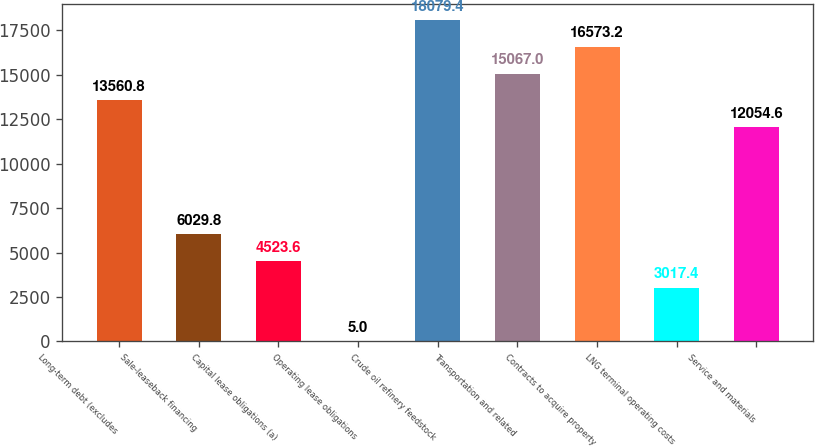<chart> <loc_0><loc_0><loc_500><loc_500><bar_chart><fcel>Long-term debt (excludes<fcel>Sale-leaseback financing<fcel>Capital lease obligations (a)<fcel>Operating lease obligations<fcel>Crude oil refinery feedstock<fcel>Transportation and related<fcel>Contracts to acquire property<fcel>LNG terminal operating costs<fcel>Service and materials<nl><fcel>13560.8<fcel>6029.8<fcel>4523.6<fcel>5<fcel>18079.4<fcel>15067<fcel>16573.2<fcel>3017.4<fcel>12054.6<nl></chart> 